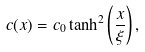Convert formula to latex. <formula><loc_0><loc_0><loc_500><loc_500>c ( x ) = c _ { 0 } \tanh ^ { 2 } \left ( \frac { x } { \xi } \right ) ,</formula> 